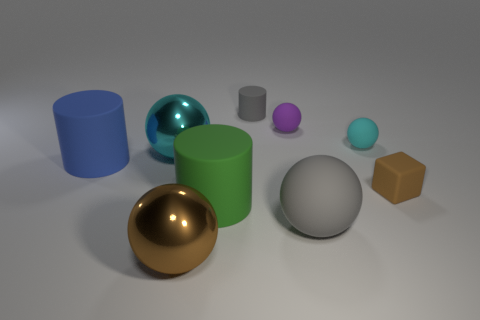How many objects are there and can you describe their shapes? There are eight objects of various shapes: two spheres, one cube, three cylinders differing in height and one of them is textured, plus two torus-shaped objects, one larger and one smaller. Are all the objects solid, or do some appear to be hollow? Most objects appear solid except for the two torus-shaped objects, which are inherently hollow due to their donut-like structure. 